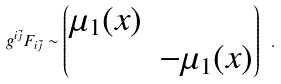Convert formula to latex. <formula><loc_0><loc_0><loc_500><loc_500>g ^ { i \bar { j } } F _ { i \bar { j } } \sim \begin{pmatrix} \mu _ { 1 } ( x ) & \\ & - \mu _ { 1 } ( x ) \end{pmatrix} \ .</formula> 